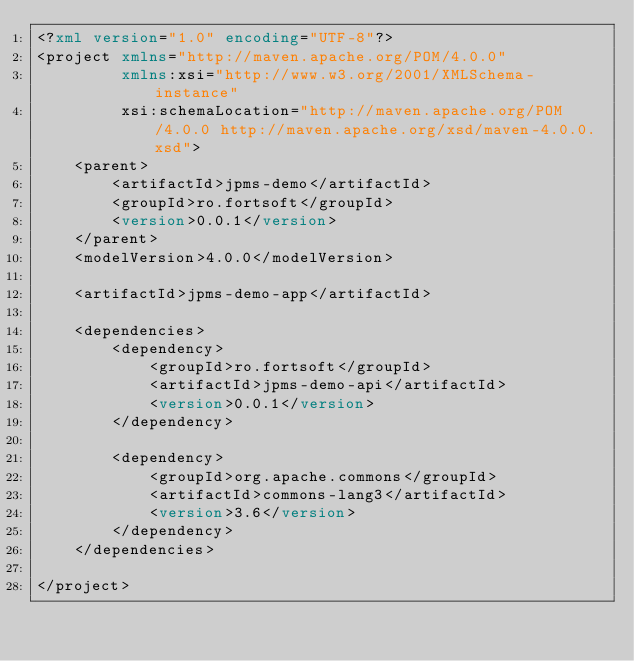Convert code to text. <code><loc_0><loc_0><loc_500><loc_500><_XML_><?xml version="1.0" encoding="UTF-8"?>
<project xmlns="http://maven.apache.org/POM/4.0.0"
         xmlns:xsi="http://www.w3.org/2001/XMLSchema-instance"
         xsi:schemaLocation="http://maven.apache.org/POM/4.0.0 http://maven.apache.org/xsd/maven-4.0.0.xsd">
    <parent>
        <artifactId>jpms-demo</artifactId>
        <groupId>ro.fortsoft</groupId>
        <version>0.0.1</version>
    </parent>
    <modelVersion>4.0.0</modelVersion>

    <artifactId>jpms-demo-app</artifactId>

    <dependencies>
        <dependency>
            <groupId>ro.fortsoft</groupId>
            <artifactId>jpms-demo-api</artifactId>
            <version>0.0.1</version>
        </dependency>

        <dependency>
            <groupId>org.apache.commons</groupId>
            <artifactId>commons-lang3</artifactId>
            <version>3.6</version>
        </dependency>
    </dependencies>

</project></code> 